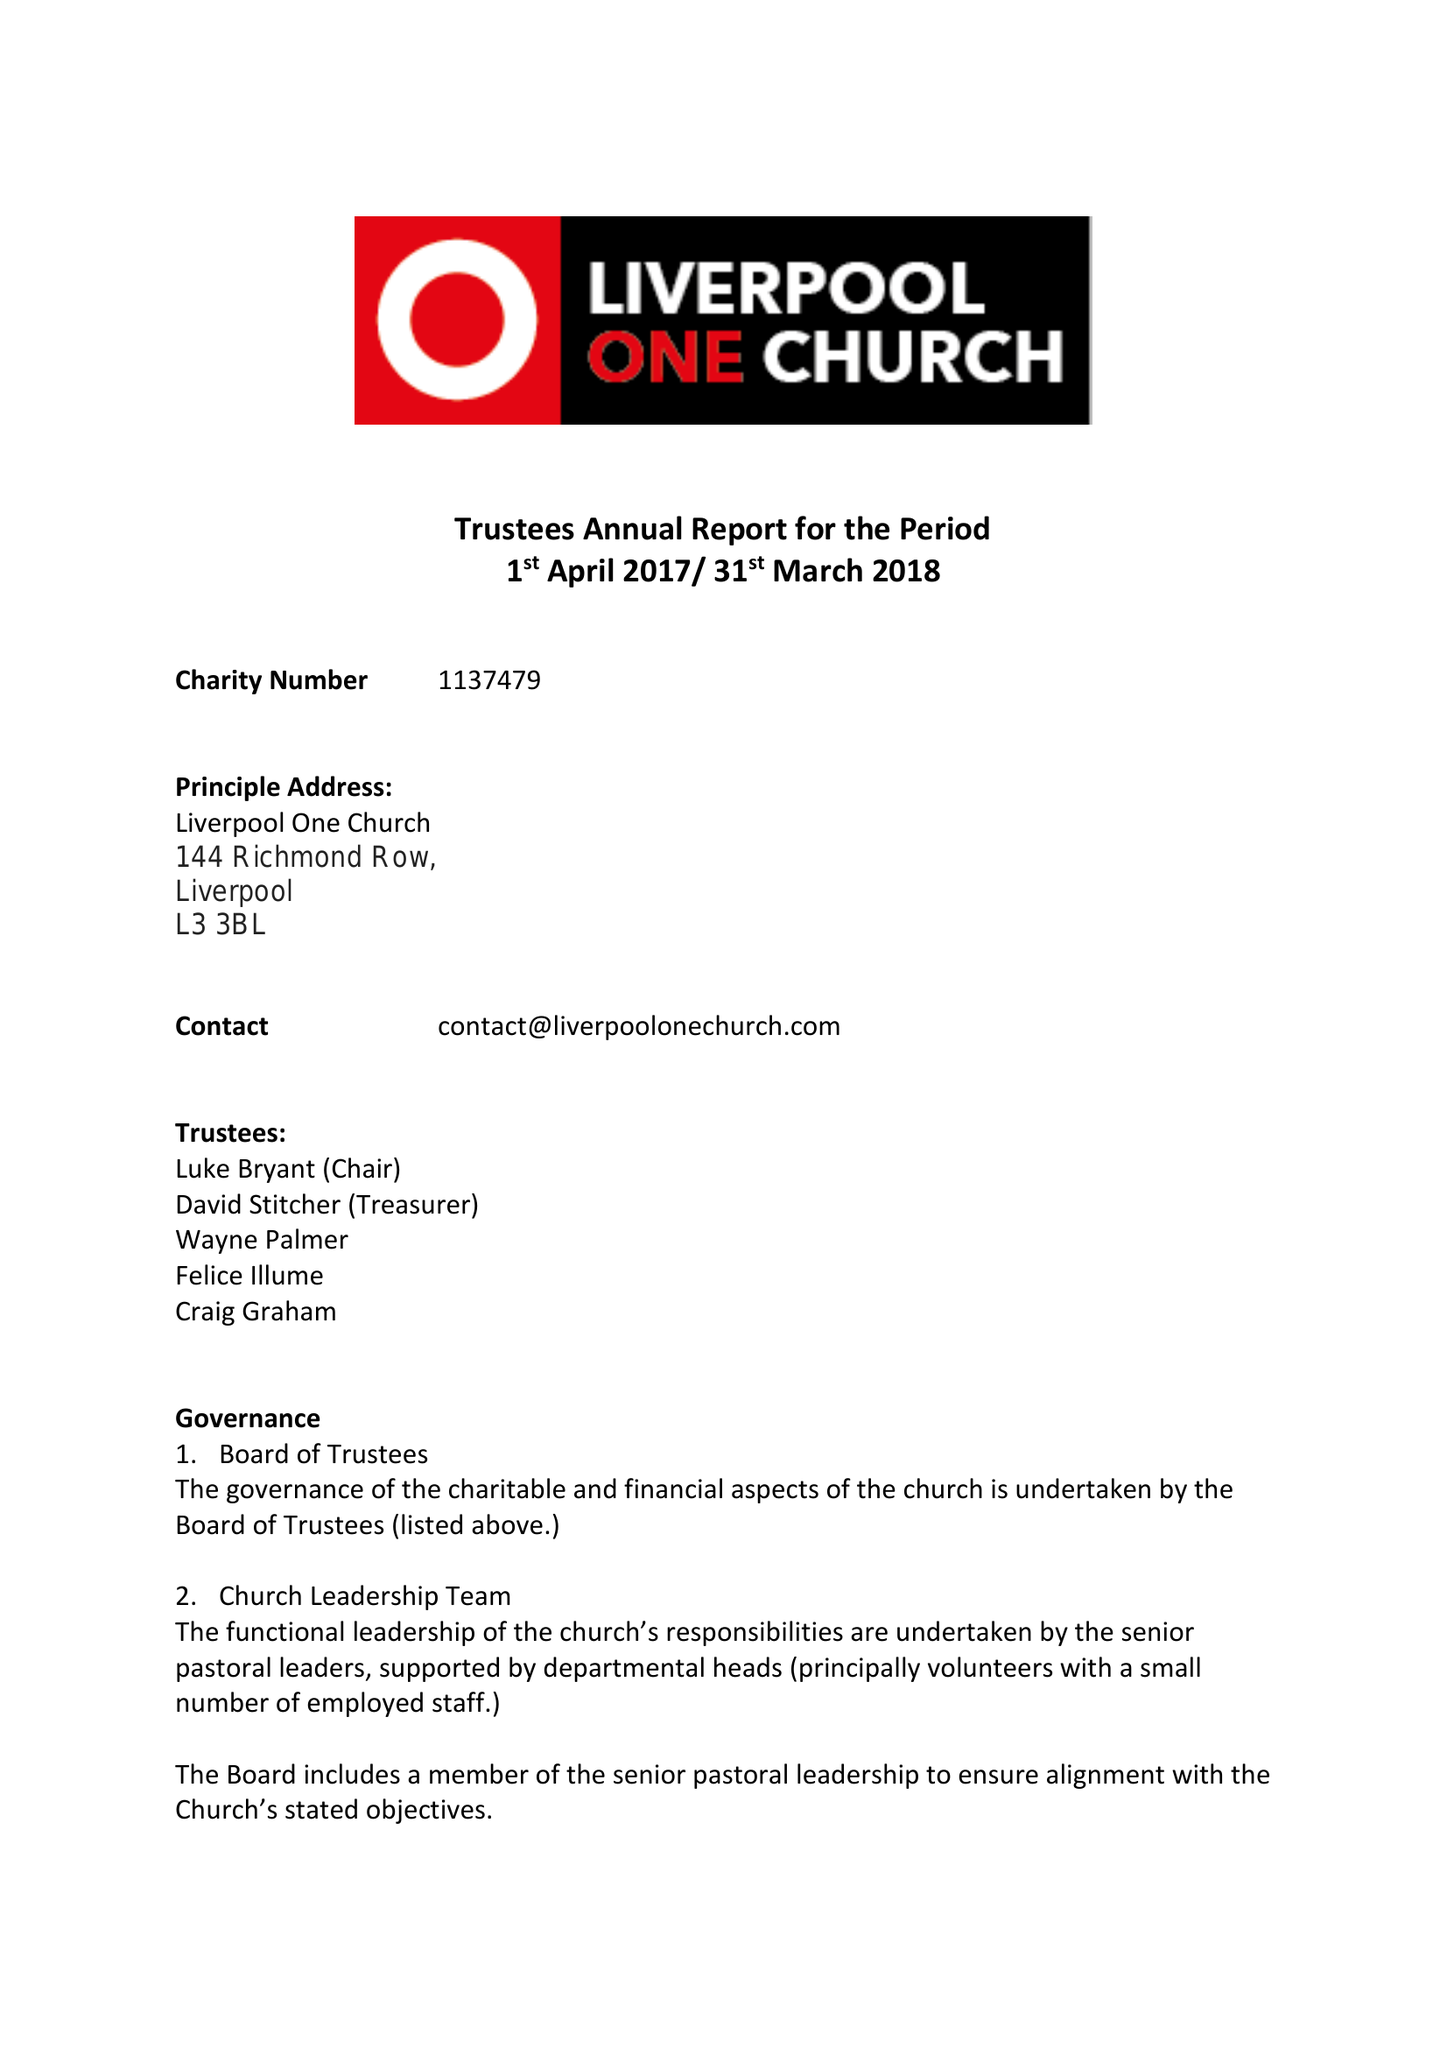What is the value for the address__post_town?
Answer the question using a single word or phrase. LIVERPOOL 